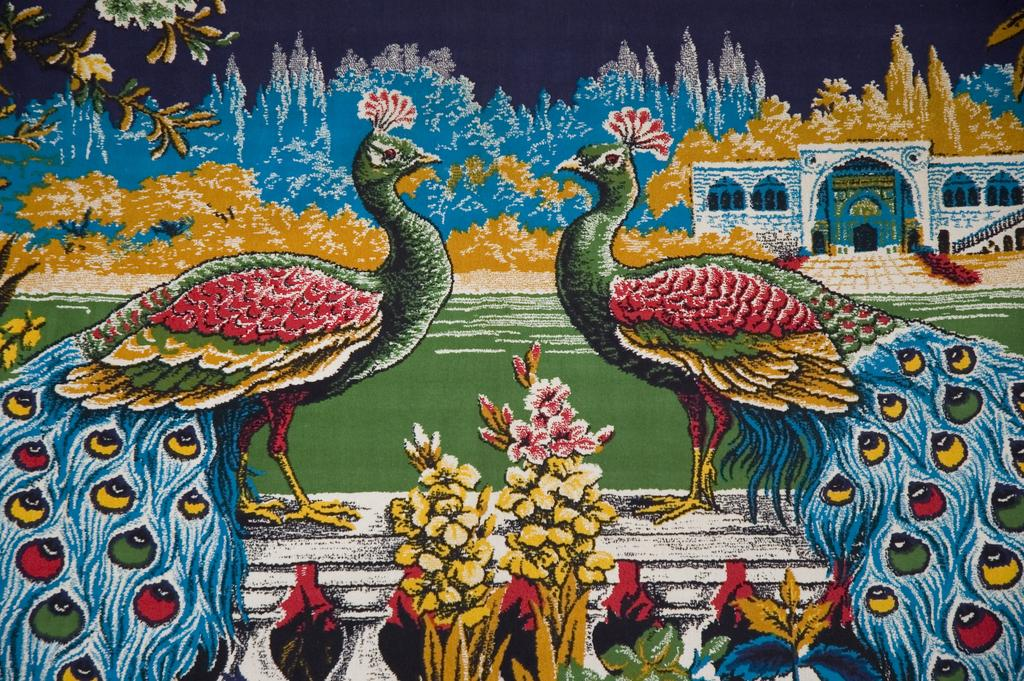What animals are depicted in the painting in the image? The painting contains two peacocks standing. What other elements are included in the painting besides the peacocks? The painting includes flowers, trees, and a house. How many children are sleeping in the bed in the image? There is no bed or children present in the image; it features a painting of two peacocks, flowers, trees, and a house. 